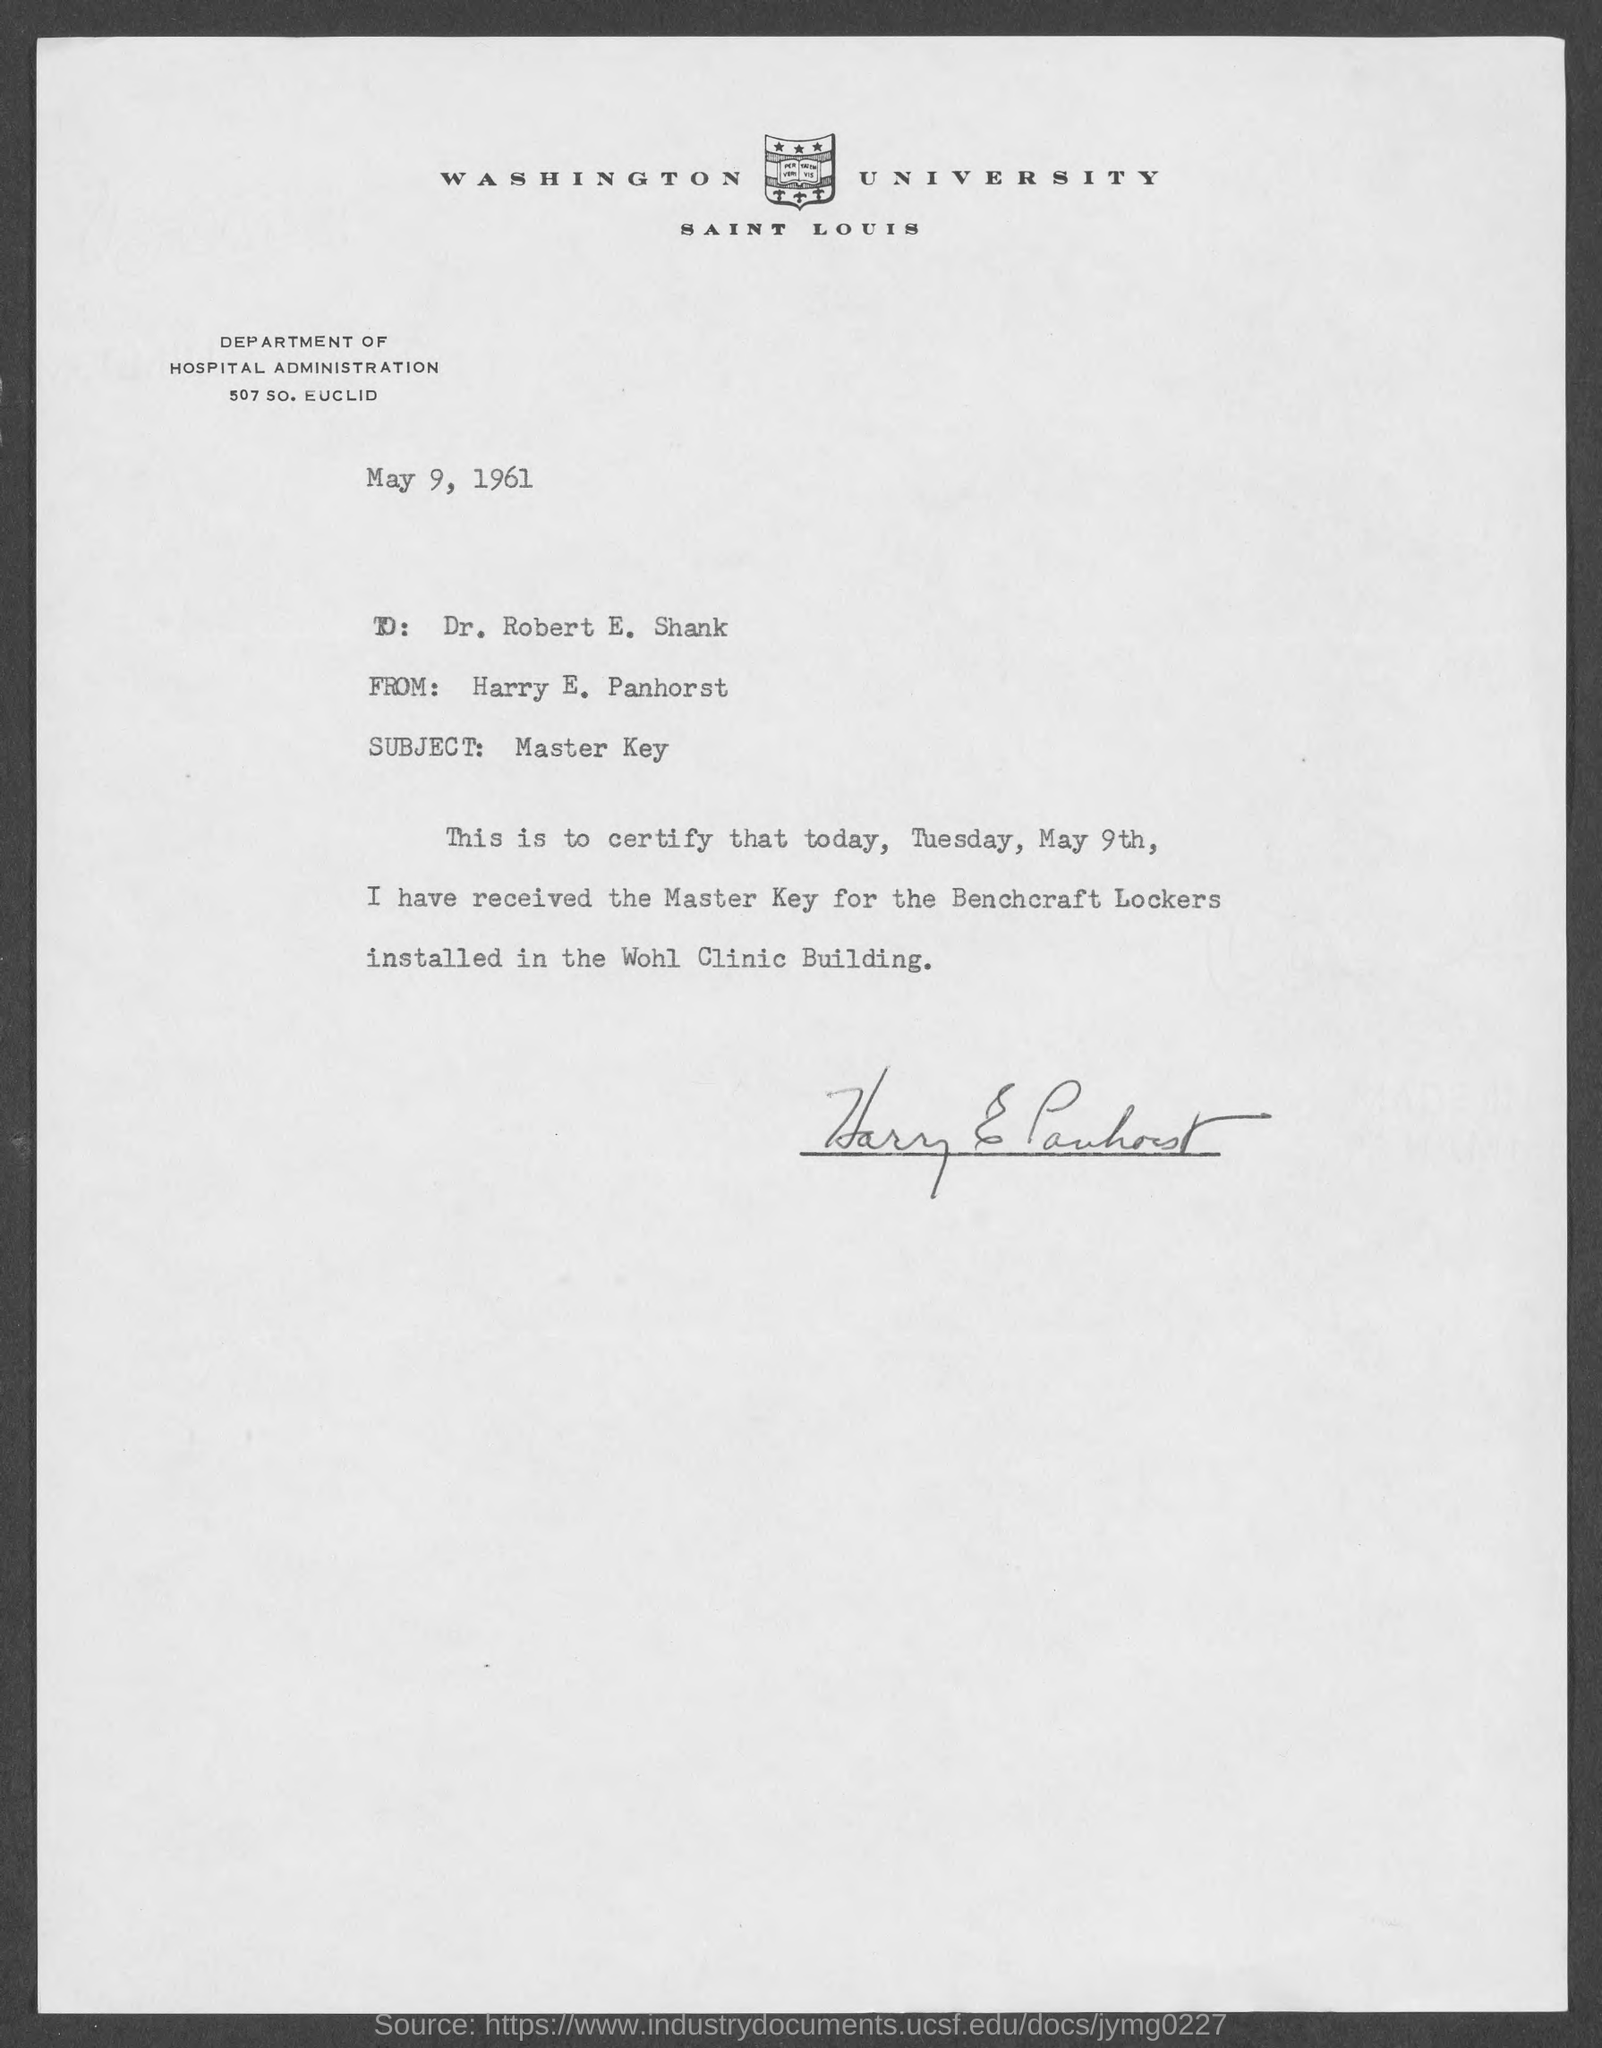In which county is washington university  located?
Offer a very short reply. Saint Louis. What is the address of department of hospital administration?
Make the answer very short. 507 SO. Euclid. When is the memorandum dated?
Ensure brevity in your answer.  May 9, 1961. What is the subject of the memorandum?
Your answer should be compact. Master Key. What is the to address in memorandum ?
Your answer should be compact. Dr. Robert E. Shank. What is from address in memorandum ?
Keep it short and to the point. Harry E. Panhorst. What day of the week was master key received ?
Offer a very short reply. Tuesday. 